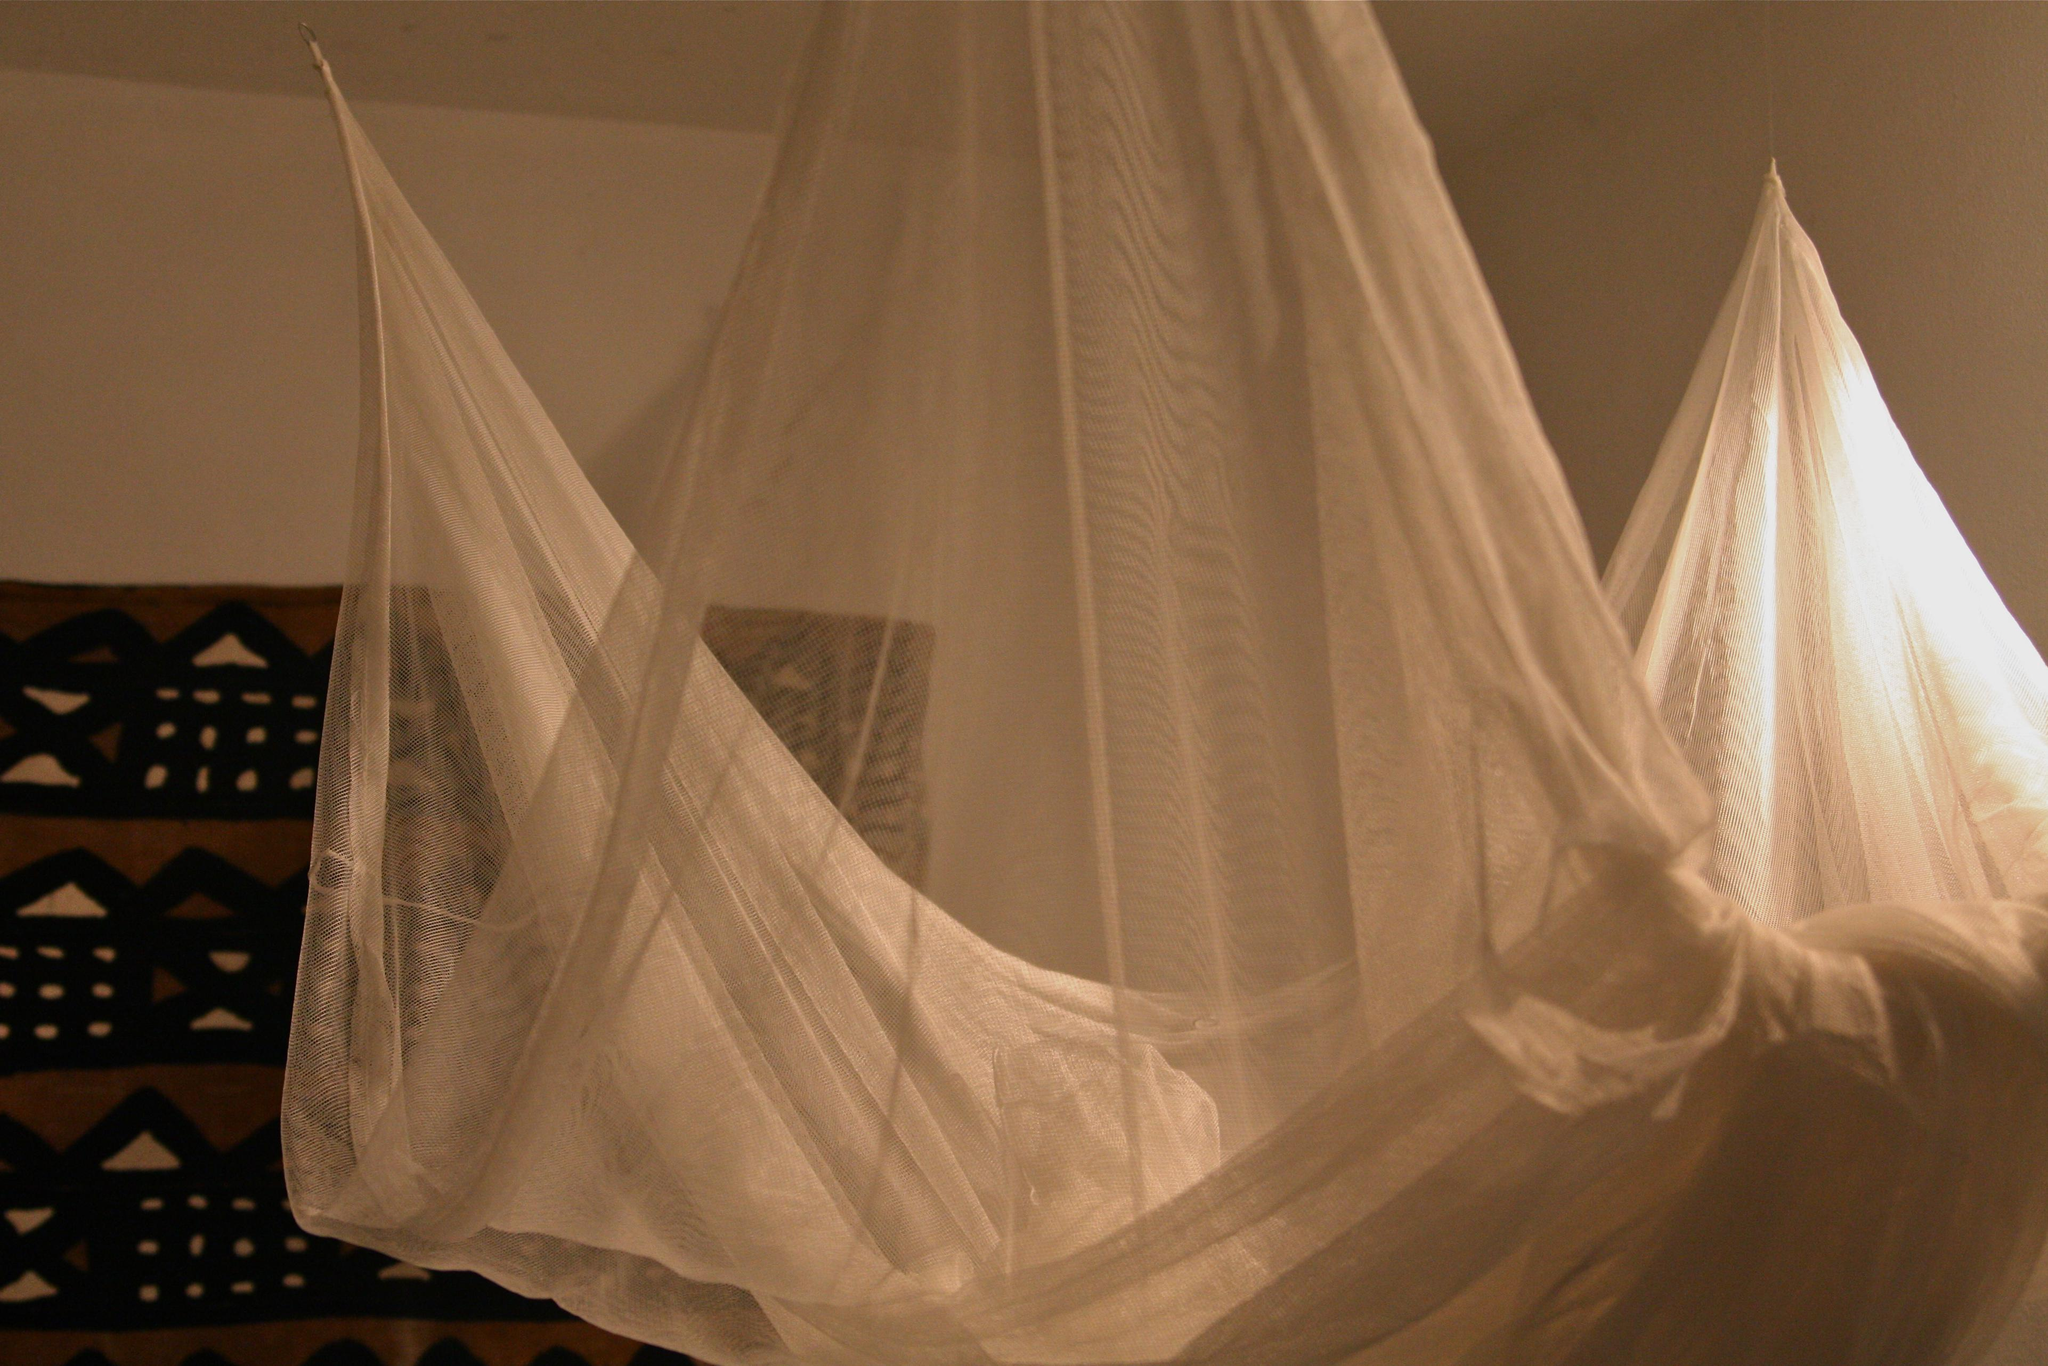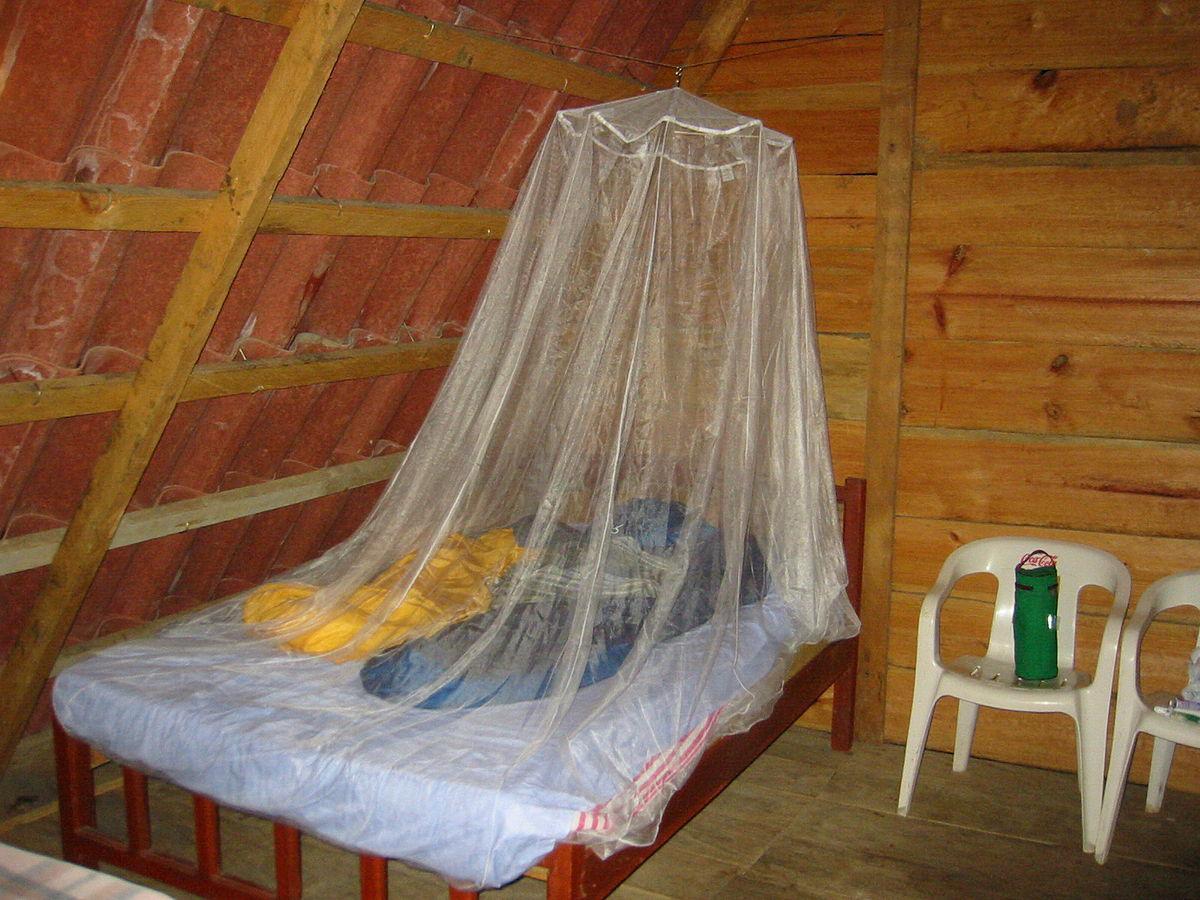The first image is the image on the left, the second image is the image on the right. Given the left and right images, does the statement "The right image shows a dome-shaped bed enclosure." hold true? Answer yes or no. No. 